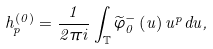Convert formula to latex. <formula><loc_0><loc_0><loc_500><loc_500>h _ { p } ^ { \left ( 0 \right ) } = \frac { 1 } { 2 \pi i } \int _ { \mathbb { T } } \widetilde { \varphi } _ { 0 } ^ { - } \left ( u \right ) u ^ { p } d u ,</formula> 